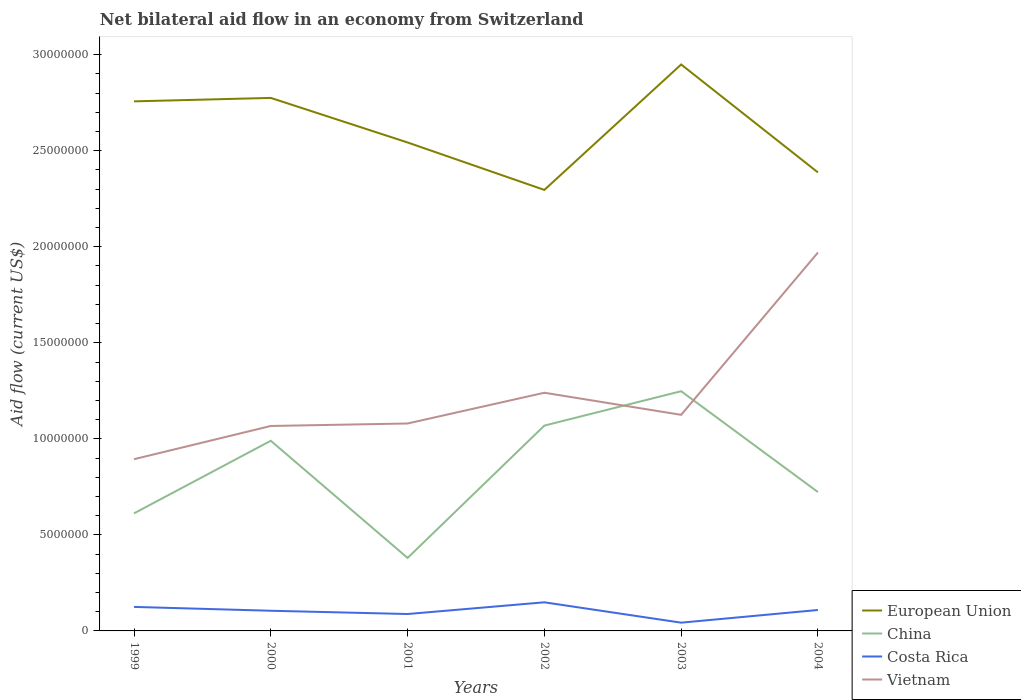Does the line corresponding to Vietnam intersect with the line corresponding to Costa Rica?
Your answer should be compact. No. In which year was the net bilateral aid flow in Vietnam maximum?
Keep it short and to the point. 1999. What is the total net bilateral aid flow in European Union in the graph?
Keep it short and to the point. 1.56e+06. What is the difference between the highest and the second highest net bilateral aid flow in Costa Rica?
Ensure brevity in your answer.  1.06e+06. Is the net bilateral aid flow in Vietnam strictly greater than the net bilateral aid flow in European Union over the years?
Ensure brevity in your answer.  Yes. How many years are there in the graph?
Your answer should be compact. 6. What is the title of the graph?
Your answer should be very brief. Net bilateral aid flow in an economy from Switzerland. What is the label or title of the X-axis?
Make the answer very short. Years. What is the Aid flow (current US$) of European Union in 1999?
Your answer should be very brief. 2.76e+07. What is the Aid flow (current US$) of China in 1999?
Your answer should be compact. 6.12e+06. What is the Aid flow (current US$) in Costa Rica in 1999?
Keep it short and to the point. 1.25e+06. What is the Aid flow (current US$) of Vietnam in 1999?
Ensure brevity in your answer.  8.94e+06. What is the Aid flow (current US$) of European Union in 2000?
Provide a succinct answer. 2.78e+07. What is the Aid flow (current US$) of China in 2000?
Provide a short and direct response. 9.90e+06. What is the Aid flow (current US$) in Costa Rica in 2000?
Keep it short and to the point. 1.05e+06. What is the Aid flow (current US$) in Vietnam in 2000?
Provide a succinct answer. 1.07e+07. What is the Aid flow (current US$) in European Union in 2001?
Your response must be concise. 2.54e+07. What is the Aid flow (current US$) of China in 2001?
Your answer should be compact. 3.80e+06. What is the Aid flow (current US$) of Costa Rica in 2001?
Offer a very short reply. 8.80e+05. What is the Aid flow (current US$) of Vietnam in 2001?
Provide a succinct answer. 1.08e+07. What is the Aid flow (current US$) in European Union in 2002?
Make the answer very short. 2.30e+07. What is the Aid flow (current US$) of China in 2002?
Your answer should be compact. 1.07e+07. What is the Aid flow (current US$) of Costa Rica in 2002?
Your response must be concise. 1.49e+06. What is the Aid flow (current US$) in Vietnam in 2002?
Your answer should be very brief. 1.24e+07. What is the Aid flow (current US$) in European Union in 2003?
Provide a short and direct response. 2.95e+07. What is the Aid flow (current US$) of China in 2003?
Your answer should be very brief. 1.25e+07. What is the Aid flow (current US$) in Costa Rica in 2003?
Your answer should be very brief. 4.30e+05. What is the Aid flow (current US$) in Vietnam in 2003?
Your answer should be compact. 1.12e+07. What is the Aid flow (current US$) in European Union in 2004?
Keep it short and to the point. 2.39e+07. What is the Aid flow (current US$) of China in 2004?
Offer a very short reply. 7.23e+06. What is the Aid flow (current US$) in Costa Rica in 2004?
Provide a succinct answer. 1.09e+06. What is the Aid flow (current US$) in Vietnam in 2004?
Make the answer very short. 1.97e+07. Across all years, what is the maximum Aid flow (current US$) in European Union?
Your response must be concise. 2.95e+07. Across all years, what is the maximum Aid flow (current US$) in China?
Give a very brief answer. 1.25e+07. Across all years, what is the maximum Aid flow (current US$) of Costa Rica?
Make the answer very short. 1.49e+06. Across all years, what is the maximum Aid flow (current US$) in Vietnam?
Your answer should be compact. 1.97e+07. Across all years, what is the minimum Aid flow (current US$) of European Union?
Make the answer very short. 2.30e+07. Across all years, what is the minimum Aid flow (current US$) in China?
Your answer should be very brief. 3.80e+06. Across all years, what is the minimum Aid flow (current US$) of Vietnam?
Make the answer very short. 8.94e+06. What is the total Aid flow (current US$) in European Union in the graph?
Give a very brief answer. 1.57e+08. What is the total Aid flow (current US$) of China in the graph?
Give a very brief answer. 5.02e+07. What is the total Aid flow (current US$) in Costa Rica in the graph?
Make the answer very short. 6.19e+06. What is the total Aid flow (current US$) in Vietnam in the graph?
Make the answer very short. 7.38e+07. What is the difference between the Aid flow (current US$) in China in 1999 and that in 2000?
Offer a terse response. -3.78e+06. What is the difference between the Aid flow (current US$) of Costa Rica in 1999 and that in 2000?
Keep it short and to the point. 2.00e+05. What is the difference between the Aid flow (current US$) of Vietnam in 1999 and that in 2000?
Offer a very short reply. -1.73e+06. What is the difference between the Aid flow (current US$) in European Union in 1999 and that in 2001?
Make the answer very short. 2.14e+06. What is the difference between the Aid flow (current US$) in China in 1999 and that in 2001?
Provide a short and direct response. 2.32e+06. What is the difference between the Aid flow (current US$) of Vietnam in 1999 and that in 2001?
Your answer should be compact. -1.86e+06. What is the difference between the Aid flow (current US$) of European Union in 1999 and that in 2002?
Give a very brief answer. 4.61e+06. What is the difference between the Aid flow (current US$) in China in 1999 and that in 2002?
Keep it short and to the point. -4.57e+06. What is the difference between the Aid flow (current US$) in Vietnam in 1999 and that in 2002?
Offer a very short reply. -3.46e+06. What is the difference between the Aid flow (current US$) in European Union in 1999 and that in 2003?
Offer a very short reply. -1.92e+06. What is the difference between the Aid flow (current US$) of China in 1999 and that in 2003?
Your answer should be compact. -6.36e+06. What is the difference between the Aid flow (current US$) of Costa Rica in 1999 and that in 2003?
Offer a terse response. 8.20e+05. What is the difference between the Aid flow (current US$) in Vietnam in 1999 and that in 2003?
Give a very brief answer. -2.31e+06. What is the difference between the Aid flow (current US$) in European Union in 1999 and that in 2004?
Provide a short and direct response. 3.70e+06. What is the difference between the Aid flow (current US$) of China in 1999 and that in 2004?
Give a very brief answer. -1.11e+06. What is the difference between the Aid flow (current US$) in Costa Rica in 1999 and that in 2004?
Ensure brevity in your answer.  1.60e+05. What is the difference between the Aid flow (current US$) of Vietnam in 1999 and that in 2004?
Provide a short and direct response. -1.08e+07. What is the difference between the Aid flow (current US$) of European Union in 2000 and that in 2001?
Keep it short and to the point. 2.32e+06. What is the difference between the Aid flow (current US$) in China in 2000 and that in 2001?
Offer a terse response. 6.10e+06. What is the difference between the Aid flow (current US$) of Costa Rica in 2000 and that in 2001?
Give a very brief answer. 1.70e+05. What is the difference between the Aid flow (current US$) of Vietnam in 2000 and that in 2001?
Provide a succinct answer. -1.30e+05. What is the difference between the Aid flow (current US$) in European Union in 2000 and that in 2002?
Ensure brevity in your answer.  4.79e+06. What is the difference between the Aid flow (current US$) of China in 2000 and that in 2002?
Provide a short and direct response. -7.90e+05. What is the difference between the Aid flow (current US$) of Costa Rica in 2000 and that in 2002?
Provide a succinct answer. -4.40e+05. What is the difference between the Aid flow (current US$) in Vietnam in 2000 and that in 2002?
Offer a very short reply. -1.73e+06. What is the difference between the Aid flow (current US$) in European Union in 2000 and that in 2003?
Provide a short and direct response. -1.74e+06. What is the difference between the Aid flow (current US$) of China in 2000 and that in 2003?
Give a very brief answer. -2.58e+06. What is the difference between the Aid flow (current US$) of Costa Rica in 2000 and that in 2003?
Give a very brief answer. 6.20e+05. What is the difference between the Aid flow (current US$) in Vietnam in 2000 and that in 2003?
Offer a terse response. -5.80e+05. What is the difference between the Aid flow (current US$) of European Union in 2000 and that in 2004?
Provide a short and direct response. 3.88e+06. What is the difference between the Aid flow (current US$) in China in 2000 and that in 2004?
Ensure brevity in your answer.  2.67e+06. What is the difference between the Aid flow (current US$) in Costa Rica in 2000 and that in 2004?
Provide a short and direct response. -4.00e+04. What is the difference between the Aid flow (current US$) in Vietnam in 2000 and that in 2004?
Your response must be concise. -9.03e+06. What is the difference between the Aid flow (current US$) in European Union in 2001 and that in 2002?
Keep it short and to the point. 2.47e+06. What is the difference between the Aid flow (current US$) of China in 2001 and that in 2002?
Provide a short and direct response. -6.89e+06. What is the difference between the Aid flow (current US$) in Costa Rica in 2001 and that in 2002?
Keep it short and to the point. -6.10e+05. What is the difference between the Aid flow (current US$) in Vietnam in 2001 and that in 2002?
Offer a terse response. -1.60e+06. What is the difference between the Aid flow (current US$) in European Union in 2001 and that in 2003?
Keep it short and to the point. -4.06e+06. What is the difference between the Aid flow (current US$) of China in 2001 and that in 2003?
Your response must be concise. -8.68e+06. What is the difference between the Aid flow (current US$) in Costa Rica in 2001 and that in 2003?
Your response must be concise. 4.50e+05. What is the difference between the Aid flow (current US$) of Vietnam in 2001 and that in 2003?
Ensure brevity in your answer.  -4.50e+05. What is the difference between the Aid flow (current US$) in European Union in 2001 and that in 2004?
Provide a succinct answer. 1.56e+06. What is the difference between the Aid flow (current US$) in China in 2001 and that in 2004?
Offer a terse response. -3.43e+06. What is the difference between the Aid flow (current US$) in Costa Rica in 2001 and that in 2004?
Keep it short and to the point. -2.10e+05. What is the difference between the Aid flow (current US$) in Vietnam in 2001 and that in 2004?
Provide a succinct answer. -8.90e+06. What is the difference between the Aid flow (current US$) of European Union in 2002 and that in 2003?
Your answer should be compact. -6.53e+06. What is the difference between the Aid flow (current US$) in China in 2002 and that in 2003?
Your response must be concise. -1.79e+06. What is the difference between the Aid flow (current US$) of Costa Rica in 2002 and that in 2003?
Provide a succinct answer. 1.06e+06. What is the difference between the Aid flow (current US$) in Vietnam in 2002 and that in 2003?
Keep it short and to the point. 1.15e+06. What is the difference between the Aid flow (current US$) in European Union in 2002 and that in 2004?
Provide a succinct answer. -9.10e+05. What is the difference between the Aid flow (current US$) in China in 2002 and that in 2004?
Offer a terse response. 3.46e+06. What is the difference between the Aid flow (current US$) of Vietnam in 2002 and that in 2004?
Offer a terse response. -7.30e+06. What is the difference between the Aid flow (current US$) in European Union in 2003 and that in 2004?
Keep it short and to the point. 5.62e+06. What is the difference between the Aid flow (current US$) of China in 2003 and that in 2004?
Provide a short and direct response. 5.25e+06. What is the difference between the Aid flow (current US$) of Costa Rica in 2003 and that in 2004?
Your answer should be very brief. -6.60e+05. What is the difference between the Aid flow (current US$) in Vietnam in 2003 and that in 2004?
Your response must be concise. -8.45e+06. What is the difference between the Aid flow (current US$) in European Union in 1999 and the Aid flow (current US$) in China in 2000?
Your answer should be compact. 1.77e+07. What is the difference between the Aid flow (current US$) of European Union in 1999 and the Aid flow (current US$) of Costa Rica in 2000?
Keep it short and to the point. 2.65e+07. What is the difference between the Aid flow (current US$) in European Union in 1999 and the Aid flow (current US$) in Vietnam in 2000?
Make the answer very short. 1.69e+07. What is the difference between the Aid flow (current US$) of China in 1999 and the Aid flow (current US$) of Costa Rica in 2000?
Offer a very short reply. 5.07e+06. What is the difference between the Aid flow (current US$) in China in 1999 and the Aid flow (current US$) in Vietnam in 2000?
Keep it short and to the point. -4.55e+06. What is the difference between the Aid flow (current US$) of Costa Rica in 1999 and the Aid flow (current US$) of Vietnam in 2000?
Your answer should be very brief. -9.42e+06. What is the difference between the Aid flow (current US$) of European Union in 1999 and the Aid flow (current US$) of China in 2001?
Keep it short and to the point. 2.38e+07. What is the difference between the Aid flow (current US$) in European Union in 1999 and the Aid flow (current US$) in Costa Rica in 2001?
Your answer should be very brief. 2.67e+07. What is the difference between the Aid flow (current US$) of European Union in 1999 and the Aid flow (current US$) of Vietnam in 2001?
Keep it short and to the point. 1.68e+07. What is the difference between the Aid flow (current US$) of China in 1999 and the Aid flow (current US$) of Costa Rica in 2001?
Offer a terse response. 5.24e+06. What is the difference between the Aid flow (current US$) of China in 1999 and the Aid flow (current US$) of Vietnam in 2001?
Offer a very short reply. -4.68e+06. What is the difference between the Aid flow (current US$) of Costa Rica in 1999 and the Aid flow (current US$) of Vietnam in 2001?
Provide a short and direct response. -9.55e+06. What is the difference between the Aid flow (current US$) in European Union in 1999 and the Aid flow (current US$) in China in 2002?
Keep it short and to the point. 1.69e+07. What is the difference between the Aid flow (current US$) in European Union in 1999 and the Aid flow (current US$) in Costa Rica in 2002?
Keep it short and to the point. 2.61e+07. What is the difference between the Aid flow (current US$) in European Union in 1999 and the Aid flow (current US$) in Vietnam in 2002?
Offer a very short reply. 1.52e+07. What is the difference between the Aid flow (current US$) of China in 1999 and the Aid flow (current US$) of Costa Rica in 2002?
Make the answer very short. 4.63e+06. What is the difference between the Aid flow (current US$) in China in 1999 and the Aid flow (current US$) in Vietnam in 2002?
Your answer should be compact. -6.28e+06. What is the difference between the Aid flow (current US$) in Costa Rica in 1999 and the Aid flow (current US$) in Vietnam in 2002?
Offer a terse response. -1.12e+07. What is the difference between the Aid flow (current US$) in European Union in 1999 and the Aid flow (current US$) in China in 2003?
Your answer should be compact. 1.51e+07. What is the difference between the Aid flow (current US$) in European Union in 1999 and the Aid flow (current US$) in Costa Rica in 2003?
Make the answer very short. 2.71e+07. What is the difference between the Aid flow (current US$) in European Union in 1999 and the Aid flow (current US$) in Vietnam in 2003?
Your response must be concise. 1.63e+07. What is the difference between the Aid flow (current US$) of China in 1999 and the Aid flow (current US$) of Costa Rica in 2003?
Make the answer very short. 5.69e+06. What is the difference between the Aid flow (current US$) of China in 1999 and the Aid flow (current US$) of Vietnam in 2003?
Your answer should be very brief. -5.13e+06. What is the difference between the Aid flow (current US$) in Costa Rica in 1999 and the Aid flow (current US$) in Vietnam in 2003?
Your answer should be very brief. -1.00e+07. What is the difference between the Aid flow (current US$) in European Union in 1999 and the Aid flow (current US$) in China in 2004?
Make the answer very short. 2.03e+07. What is the difference between the Aid flow (current US$) of European Union in 1999 and the Aid flow (current US$) of Costa Rica in 2004?
Provide a short and direct response. 2.65e+07. What is the difference between the Aid flow (current US$) of European Union in 1999 and the Aid flow (current US$) of Vietnam in 2004?
Offer a very short reply. 7.87e+06. What is the difference between the Aid flow (current US$) in China in 1999 and the Aid flow (current US$) in Costa Rica in 2004?
Ensure brevity in your answer.  5.03e+06. What is the difference between the Aid flow (current US$) of China in 1999 and the Aid flow (current US$) of Vietnam in 2004?
Offer a very short reply. -1.36e+07. What is the difference between the Aid flow (current US$) of Costa Rica in 1999 and the Aid flow (current US$) of Vietnam in 2004?
Offer a very short reply. -1.84e+07. What is the difference between the Aid flow (current US$) in European Union in 2000 and the Aid flow (current US$) in China in 2001?
Provide a succinct answer. 2.40e+07. What is the difference between the Aid flow (current US$) of European Union in 2000 and the Aid flow (current US$) of Costa Rica in 2001?
Offer a very short reply. 2.69e+07. What is the difference between the Aid flow (current US$) in European Union in 2000 and the Aid flow (current US$) in Vietnam in 2001?
Offer a terse response. 1.70e+07. What is the difference between the Aid flow (current US$) of China in 2000 and the Aid flow (current US$) of Costa Rica in 2001?
Your response must be concise. 9.02e+06. What is the difference between the Aid flow (current US$) in China in 2000 and the Aid flow (current US$) in Vietnam in 2001?
Provide a short and direct response. -9.00e+05. What is the difference between the Aid flow (current US$) in Costa Rica in 2000 and the Aid flow (current US$) in Vietnam in 2001?
Make the answer very short. -9.75e+06. What is the difference between the Aid flow (current US$) of European Union in 2000 and the Aid flow (current US$) of China in 2002?
Your response must be concise. 1.71e+07. What is the difference between the Aid flow (current US$) of European Union in 2000 and the Aid flow (current US$) of Costa Rica in 2002?
Provide a short and direct response. 2.63e+07. What is the difference between the Aid flow (current US$) in European Union in 2000 and the Aid flow (current US$) in Vietnam in 2002?
Your answer should be very brief. 1.54e+07. What is the difference between the Aid flow (current US$) of China in 2000 and the Aid flow (current US$) of Costa Rica in 2002?
Keep it short and to the point. 8.41e+06. What is the difference between the Aid flow (current US$) in China in 2000 and the Aid flow (current US$) in Vietnam in 2002?
Your response must be concise. -2.50e+06. What is the difference between the Aid flow (current US$) of Costa Rica in 2000 and the Aid flow (current US$) of Vietnam in 2002?
Make the answer very short. -1.14e+07. What is the difference between the Aid flow (current US$) in European Union in 2000 and the Aid flow (current US$) in China in 2003?
Give a very brief answer. 1.53e+07. What is the difference between the Aid flow (current US$) in European Union in 2000 and the Aid flow (current US$) in Costa Rica in 2003?
Ensure brevity in your answer.  2.73e+07. What is the difference between the Aid flow (current US$) of European Union in 2000 and the Aid flow (current US$) of Vietnam in 2003?
Provide a succinct answer. 1.65e+07. What is the difference between the Aid flow (current US$) in China in 2000 and the Aid flow (current US$) in Costa Rica in 2003?
Ensure brevity in your answer.  9.47e+06. What is the difference between the Aid flow (current US$) in China in 2000 and the Aid flow (current US$) in Vietnam in 2003?
Keep it short and to the point. -1.35e+06. What is the difference between the Aid flow (current US$) of Costa Rica in 2000 and the Aid flow (current US$) of Vietnam in 2003?
Your answer should be very brief. -1.02e+07. What is the difference between the Aid flow (current US$) in European Union in 2000 and the Aid flow (current US$) in China in 2004?
Offer a very short reply. 2.05e+07. What is the difference between the Aid flow (current US$) of European Union in 2000 and the Aid flow (current US$) of Costa Rica in 2004?
Keep it short and to the point. 2.67e+07. What is the difference between the Aid flow (current US$) of European Union in 2000 and the Aid flow (current US$) of Vietnam in 2004?
Your response must be concise. 8.05e+06. What is the difference between the Aid flow (current US$) in China in 2000 and the Aid flow (current US$) in Costa Rica in 2004?
Provide a short and direct response. 8.81e+06. What is the difference between the Aid flow (current US$) in China in 2000 and the Aid flow (current US$) in Vietnam in 2004?
Your answer should be compact. -9.80e+06. What is the difference between the Aid flow (current US$) of Costa Rica in 2000 and the Aid flow (current US$) of Vietnam in 2004?
Provide a short and direct response. -1.86e+07. What is the difference between the Aid flow (current US$) of European Union in 2001 and the Aid flow (current US$) of China in 2002?
Provide a succinct answer. 1.47e+07. What is the difference between the Aid flow (current US$) in European Union in 2001 and the Aid flow (current US$) in Costa Rica in 2002?
Keep it short and to the point. 2.39e+07. What is the difference between the Aid flow (current US$) in European Union in 2001 and the Aid flow (current US$) in Vietnam in 2002?
Make the answer very short. 1.30e+07. What is the difference between the Aid flow (current US$) of China in 2001 and the Aid flow (current US$) of Costa Rica in 2002?
Your answer should be compact. 2.31e+06. What is the difference between the Aid flow (current US$) of China in 2001 and the Aid flow (current US$) of Vietnam in 2002?
Provide a short and direct response. -8.60e+06. What is the difference between the Aid flow (current US$) in Costa Rica in 2001 and the Aid flow (current US$) in Vietnam in 2002?
Provide a short and direct response. -1.15e+07. What is the difference between the Aid flow (current US$) of European Union in 2001 and the Aid flow (current US$) of China in 2003?
Provide a succinct answer. 1.30e+07. What is the difference between the Aid flow (current US$) in European Union in 2001 and the Aid flow (current US$) in Costa Rica in 2003?
Keep it short and to the point. 2.50e+07. What is the difference between the Aid flow (current US$) in European Union in 2001 and the Aid flow (current US$) in Vietnam in 2003?
Provide a succinct answer. 1.42e+07. What is the difference between the Aid flow (current US$) of China in 2001 and the Aid flow (current US$) of Costa Rica in 2003?
Keep it short and to the point. 3.37e+06. What is the difference between the Aid flow (current US$) of China in 2001 and the Aid flow (current US$) of Vietnam in 2003?
Offer a very short reply. -7.45e+06. What is the difference between the Aid flow (current US$) of Costa Rica in 2001 and the Aid flow (current US$) of Vietnam in 2003?
Your response must be concise. -1.04e+07. What is the difference between the Aid flow (current US$) in European Union in 2001 and the Aid flow (current US$) in China in 2004?
Give a very brief answer. 1.82e+07. What is the difference between the Aid flow (current US$) of European Union in 2001 and the Aid flow (current US$) of Costa Rica in 2004?
Your answer should be compact. 2.43e+07. What is the difference between the Aid flow (current US$) of European Union in 2001 and the Aid flow (current US$) of Vietnam in 2004?
Offer a terse response. 5.73e+06. What is the difference between the Aid flow (current US$) of China in 2001 and the Aid flow (current US$) of Costa Rica in 2004?
Offer a terse response. 2.71e+06. What is the difference between the Aid flow (current US$) of China in 2001 and the Aid flow (current US$) of Vietnam in 2004?
Provide a short and direct response. -1.59e+07. What is the difference between the Aid flow (current US$) in Costa Rica in 2001 and the Aid flow (current US$) in Vietnam in 2004?
Offer a terse response. -1.88e+07. What is the difference between the Aid flow (current US$) of European Union in 2002 and the Aid flow (current US$) of China in 2003?
Your answer should be very brief. 1.05e+07. What is the difference between the Aid flow (current US$) in European Union in 2002 and the Aid flow (current US$) in Costa Rica in 2003?
Keep it short and to the point. 2.25e+07. What is the difference between the Aid flow (current US$) of European Union in 2002 and the Aid flow (current US$) of Vietnam in 2003?
Provide a succinct answer. 1.17e+07. What is the difference between the Aid flow (current US$) of China in 2002 and the Aid flow (current US$) of Costa Rica in 2003?
Your answer should be very brief. 1.03e+07. What is the difference between the Aid flow (current US$) of China in 2002 and the Aid flow (current US$) of Vietnam in 2003?
Keep it short and to the point. -5.60e+05. What is the difference between the Aid flow (current US$) in Costa Rica in 2002 and the Aid flow (current US$) in Vietnam in 2003?
Your answer should be very brief. -9.76e+06. What is the difference between the Aid flow (current US$) in European Union in 2002 and the Aid flow (current US$) in China in 2004?
Offer a terse response. 1.57e+07. What is the difference between the Aid flow (current US$) in European Union in 2002 and the Aid flow (current US$) in Costa Rica in 2004?
Make the answer very short. 2.19e+07. What is the difference between the Aid flow (current US$) of European Union in 2002 and the Aid flow (current US$) of Vietnam in 2004?
Your answer should be compact. 3.26e+06. What is the difference between the Aid flow (current US$) of China in 2002 and the Aid flow (current US$) of Costa Rica in 2004?
Offer a terse response. 9.60e+06. What is the difference between the Aid flow (current US$) in China in 2002 and the Aid flow (current US$) in Vietnam in 2004?
Provide a short and direct response. -9.01e+06. What is the difference between the Aid flow (current US$) of Costa Rica in 2002 and the Aid flow (current US$) of Vietnam in 2004?
Make the answer very short. -1.82e+07. What is the difference between the Aid flow (current US$) in European Union in 2003 and the Aid flow (current US$) in China in 2004?
Ensure brevity in your answer.  2.23e+07. What is the difference between the Aid flow (current US$) of European Union in 2003 and the Aid flow (current US$) of Costa Rica in 2004?
Keep it short and to the point. 2.84e+07. What is the difference between the Aid flow (current US$) in European Union in 2003 and the Aid flow (current US$) in Vietnam in 2004?
Make the answer very short. 9.79e+06. What is the difference between the Aid flow (current US$) in China in 2003 and the Aid flow (current US$) in Costa Rica in 2004?
Your answer should be compact. 1.14e+07. What is the difference between the Aid flow (current US$) in China in 2003 and the Aid flow (current US$) in Vietnam in 2004?
Make the answer very short. -7.22e+06. What is the difference between the Aid flow (current US$) in Costa Rica in 2003 and the Aid flow (current US$) in Vietnam in 2004?
Keep it short and to the point. -1.93e+07. What is the average Aid flow (current US$) of European Union per year?
Your response must be concise. 2.62e+07. What is the average Aid flow (current US$) of China per year?
Keep it short and to the point. 8.37e+06. What is the average Aid flow (current US$) of Costa Rica per year?
Keep it short and to the point. 1.03e+06. What is the average Aid flow (current US$) in Vietnam per year?
Your response must be concise. 1.23e+07. In the year 1999, what is the difference between the Aid flow (current US$) in European Union and Aid flow (current US$) in China?
Give a very brief answer. 2.14e+07. In the year 1999, what is the difference between the Aid flow (current US$) in European Union and Aid flow (current US$) in Costa Rica?
Your answer should be compact. 2.63e+07. In the year 1999, what is the difference between the Aid flow (current US$) in European Union and Aid flow (current US$) in Vietnam?
Your response must be concise. 1.86e+07. In the year 1999, what is the difference between the Aid flow (current US$) in China and Aid flow (current US$) in Costa Rica?
Your answer should be very brief. 4.87e+06. In the year 1999, what is the difference between the Aid flow (current US$) of China and Aid flow (current US$) of Vietnam?
Ensure brevity in your answer.  -2.82e+06. In the year 1999, what is the difference between the Aid flow (current US$) of Costa Rica and Aid flow (current US$) of Vietnam?
Ensure brevity in your answer.  -7.69e+06. In the year 2000, what is the difference between the Aid flow (current US$) in European Union and Aid flow (current US$) in China?
Provide a succinct answer. 1.78e+07. In the year 2000, what is the difference between the Aid flow (current US$) of European Union and Aid flow (current US$) of Costa Rica?
Keep it short and to the point. 2.67e+07. In the year 2000, what is the difference between the Aid flow (current US$) in European Union and Aid flow (current US$) in Vietnam?
Provide a succinct answer. 1.71e+07. In the year 2000, what is the difference between the Aid flow (current US$) in China and Aid flow (current US$) in Costa Rica?
Ensure brevity in your answer.  8.85e+06. In the year 2000, what is the difference between the Aid flow (current US$) in China and Aid flow (current US$) in Vietnam?
Ensure brevity in your answer.  -7.70e+05. In the year 2000, what is the difference between the Aid flow (current US$) in Costa Rica and Aid flow (current US$) in Vietnam?
Your answer should be compact. -9.62e+06. In the year 2001, what is the difference between the Aid flow (current US$) in European Union and Aid flow (current US$) in China?
Ensure brevity in your answer.  2.16e+07. In the year 2001, what is the difference between the Aid flow (current US$) of European Union and Aid flow (current US$) of Costa Rica?
Keep it short and to the point. 2.46e+07. In the year 2001, what is the difference between the Aid flow (current US$) of European Union and Aid flow (current US$) of Vietnam?
Provide a succinct answer. 1.46e+07. In the year 2001, what is the difference between the Aid flow (current US$) in China and Aid flow (current US$) in Costa Rica?
Provide a succinct answer. 2.92e+06. In the year 2001, what is the difference between the Aid flow (current US$) of China and Aid flow (current US$) of Vietnam?
Offer a very short reply. -7.00e+06. In the year 2001, what is the difference between the Aid flow (current US$) of Costa Rica and Aid flow (current US$) of Vietnam?
Make the answer very short. -9.92e+06. In the year 2002, what is the difference between the Aid flow (current US$) in European Union and Aid flow (current US$) in China?
Ensure brevity in your answer.  1.23e+07. In the year 2002, what is the difference between the Aid flow (current US$) of European Union and Aid flow (current US$) of Costa Rica?
Make the answer very short. 2.15e+07. In the year 2002, what is the difference between the Aid flow (current US$) in European Union and Aid flow (current US$) in Vietnam?
Offer a terse response. 1.06e+07. In the year 2002, what is the difference between the Aid flow (current US$) of China and Aid flow (current US$) of Costa Rica?
Keep it short and to the point. 9.20e+06. In the year 2002, what is the difference between the Aid flow (current US$) of China and Aid flow (current US$) of Vietnam?
Give a very brief answer. -1.71e+06. In the year 2002, what is the difference between the Aid flow (current US$) of Costa Rica and Aid flow (current US$) of Vietnam?
Ensure brevity in your answer.  -1.09e+07. In the year 2003, what is the difference between the Aid flow (current US$) in European Union and Aid flow (current US$) in China?
Provide a short and direct response. 1.70e+07. In the year 2003, what is the difference between the Aid flow (current US$) of European Union and Aid flow (current US$) of Costa Rica?
Make the answer very short. 2.91e+07. In the year 2003, what is the difference between the Aid flow (current US$) in European Union and Aid flow (current US$) in Vietnam?
Your answer should be compact. 1.82e+07. In the year 2003, what is the difference between the Aid flow (current US$) of China and Aid flow (current US$) of Costa Rica?
Ensure brevity in your answer.  1.20e+07. In the year 2003, what is the difference between the Aid flow (current US$) in China and Aid flow (current US$) in Vietnam?
Keep it short and to the point. 1.23e+06. In the year 2003, what is the difference between the Aid flow (current US$) in Costa Rica and Aid flow (current US$) in Vietnam?
Ensure brevity in your answer.  -1.08e+07. In the year 2004, what is the difference between the Aid flow (current US$) of European Union and Aid flow (current US$) of China?
Give a very brief answer. 1.66e+07. In the year 2004, what is the difference between the Aid flow (current US$) in European Union and Aid flow (current US$) in Costa Rica?
Provide a succinct answer. 2.28e+07. In the year 2004, what is the difference between the Aid flow (current US$) in European Union and Aid flow (current US$) in Vietnam?
Ensure brevity in your answer.  4.17e+06. In the year 2004, what is the difference between the Aid flow (current US$) of China and Aid flow (current US$) of Costa Rica?
Give a very brief answer. 6.14e+06. In the year 2004, what is the difference between the Aid flow (current US$) in China and Aid flow (current US$) in Vietnam?
Offer a terse response. -1.25e+07. In the year 2004, what is the difference between the Aid flow (current US$) of Costa Rica and Aid flow (current US$) of Vietnam?
Your answer should be compact. -1.86e+07. What is the ratio of the Aid flow (current US$) in China in 1999 to that in 2000?
Your response must be concise. 0.62. What is the ratio of the Aid flow (current US$) of Costa Rica in 1999 to that in 2000?
Make the answer very short. 1.19. What is the ratio of the Aid flow (current US$) in Vietnam in 1999 to that in 2000?
Your response must be concise. 0.84. What is the ratio of the Aid flow (current US$) of European Union in 1999 to that in 2001?
Ensure brevity in your answer.  1.08. What is the ratio of the Aid flow (current US$) of China in 1999 to that in 2001?
Offer a very short reply. 1.61. What is the ratio of the Aid flow (current US$) of Costa Rica in 1999 to that in 2001?
Your answer should be very brief. 1.42. What is the ratio of the Aid flow (current US$) of Vietnam in 1999 to that in 2001?
Offer a very short reply. 0.83. What is the ratio of the Aid flow (current US$) in European Union in 1999 to that in 2002?
Provide a succinct answer. 1.2. What is the ratio of the Aid flow (current US$) of China in 1999 to that in 2002?
Give a very brief answer. 0.57. What is the ratio of the Aid flow (current US$) of Costa Rica in 1999 to that in 2002?
Offer a very short reply. 0.84. What is the ratio of the Aid flow (current US$) of Vietnam in 1999 to that in 2002?
Ensure brevity in your answer.  0.72. What is the ratio of the Aid flow (current US$) of European Union in 1999 to that in 2003?
Ensure brevity in your answer.  0.93. What is the ratio of the Aid flow (current US$) in China in 1999 to that in 2003?
Make the answer very short. 0.49. What is the ratio of the Aid flow (current US$) of Costa Rica in 1999 to that in 2003?
Offer a very short reply. 2.91. What is the ratio of the Aid flow (current US$) in Vietnam in 1999 to that in 2003?
Offer a very short reply. 0.79. What is the ratio of the Aid flow (current US$) of European Union in 1999 to that in 2004?
Provide a short and direct response. 1.16. What is the ratio of the Aid flow (current US$) of China in 1999 to that in 2004?
Your response must be concise. 0.85. What is the ratio of the Aid flow (current US$) in Costa Rica in 1999 to that in 2004?
Your answer should be very brief. 1.15. What is the ratio of the Aid flow (current US$) in Vietnam in 1999 to that in 2004?
Your answer should be very brief. 0.45. What is the ratio of the Aid flow (current US$) of European Union in 2000 to that in 2001?
Ensure brevity in your answer.  1.09. What is the ratio of the Aid flow (current US$) of China in 2000 to that in 2001?
Your answer should be compact. 2.61. What is the ratio of the Aid flow (current US$) of Costa Rica in 2000 to that in 2001?
Offer a terse response. 1.19. What is the ratio of the Aid flow (current US$) in European Union in 2000 to that in 2002?
Ensure brevity in your answer.  1.21. What is the ratio of the Aid flow (current US$) of China in 2000 to that in 2002?
Provide a succinct answer. 0.93. What is the ratio of the Aid flow (current US$) in Costa Rica in 2000 to that in 2002?
Your response must be concise. 0.7. What is the ratio of the Aid flow (current US$) in Vietnam in 2000 to that in 2002?
Ensure brevity in your answer.  0.86. What is the ratio of the Aid flow (current US$) of European Union in 2000 to that in 2003?
Provide a short and direct response. 0.94. What is the ratio of the Aid flow (current US$) of China in 2000 to that in 2003?
Offer a very short reply. 0.79. What is the ratio of the Aid flow (current US$) in Costa Rica in 2000 to that in 2003?
Offer a terse response. 2.44. What is the ratio of the Aid flow (current US$) in Vietnam in 2000 to that in 2003?
Offer a terse response. 0.95. What is the ratio of the Aid flow (current US$) of European Union in 2000 to that in 2004?
Offer a terse response. 1.16. What is the ratio of the Aid flow (current US$) of China in 2000 to that in 2004?
Your answer should be very brief. 1.37. What is the ratio of the Aid flow (current US$) of Costa Rica in 2000 to that in 2004?
Your answer should be compact. 0.96. What is the ratio of the Aid flow (current US$) in Vietnam in 2000 to that in 2004?
Your answer should be compact. 0.54. What is the ratio of the Aid flow (current US$) in European Union in 2001 to that in 2002?
Make the answer very short. 1.11. What is the ratio of the Aid flow (current US$) in China in 2001 to that in 2002?
Offer a very short reply. 0.36. What is the ratio of the Aid flow (current US$) in Costa Rica in 2001 to that in 2002?
Ensure brevity in your answer.  0.59. What is the ratio of the Aid flow (current US$) in Vietnam in 2001 to that in 2002?
Offer a terse response. 0.87. What is the ratio of the Aid flow (current US$) of European Union in 2001 to that in 2003?
Provide a short and direct response. 0.86. What is the ratio of the Aid flow (current US$) of China in 2001 to that in 2003?
Your answer should be very brief. 0.3. What is the ratio of the Aid flow (current US$) in Costa Rica in 2001 to that in 2003?
Your answer should be very brief. 2.05. What is the ratio of the Aid flow (current US$) of European Union in 2001 to that in 2004?
Provide a short and direct response. 1.07. What is the ratio of the Aid flow (current US$) of China in 2001 to that in 2004?
Your response must be concise. 0.53. What is the ratio of the Aid flow (current US$) of Costa Rica in 2001 to that in 2004?
Provide a short and direct response. 0.81. What is the ratio of the Aid flow (current US$) in Vietnam in 2001 to that in 2004?
Ensure brevity in your answer.  0.55. What is the ratio of the Aid flow (current US$) of European Union in 2002 to that in 2003?
Keep it short and to the point. 0.78. What is the ratio of the Aid flow (current US$) of China in 2002 to that in 2003?
Give a very brief answer. 0.86. What is the ratio of the Aid flow (current US$) in Costa Rica in 2002 to that in 2003?
Provide a succinct answer. 3.47. What is the ratio of the Aid flow (current US$) of Vietnam in 2002 to that in 2003?
Your response must be concise. 1.1. What is the ratio of the Aid flow (current US$) in European Union in 2002 to that in 2004?
Keep it short and to the point. 0.96. What is the ratio of the Aid flow (current US$) in China in 2002 to that in 2004?
Make the answer very short. 1.48. What is the ratio of the Aid flow (current US$) of Costa Rica in 2002 to that in 2004?
Make the answer very short. 1.37. What is the ratio of the Aid flow (current US$) in Vietnam in 2002 to that in 2004?
Keep it short and to the point. 0.63. What is the ratio of the Aid flow (current US$) of European Union in 2003 to that in 2004?
Provide a succinct answer. 1.24. What is the ratio of the Aid flow (current US$) of China in 2003 to that in 2004?
Ensure brevity in your answer.  1.73. What is the ratio of the Aid flow (current US$) of Costa Rica in 2003 to that in 2004?
Give a very brief answer. 0.39. What is the ratio of the Aid flow (current US$) of Vietnam in 2003 to that in 2004?
Give a very brief answer. 0.57. What is the difference between the highest and the second highest Aid flow (current US$) in European Union?
Offer a terse response. 1.74e+06. What is the difference between the highest and the second highest Aid flow (current US$) in China?
Ensure brevity in your answer.  1.79e+06. What is the difference between the highest and the second highest Aid flow (current US$) of Costa Rica?
Ensure brevity in your answer.  2.40e+05. What is the difference between the highest and the second highest Aid flow (current US$) of Vietnam?
Give a very brief answer. 7.30e+06. What is the difference between the highest and the lowest Aid flow (current US$) of European Union?
Provide a short and direct response. 6.53e+06. What is the difference between the highest and the lowest Aid flow (current US$) of China?
Your answer should be compact. 8.68e+06. What is the difference between the highest and the lowest Aid flow (current US$) in Costa Rica?
Ensure brevity in your answer.  1.06e+06. What is the difference between the highest and the lowest Aid flow (current US$) in Vietnam?
Ensure brevity in your answer.  1.08e+07. 